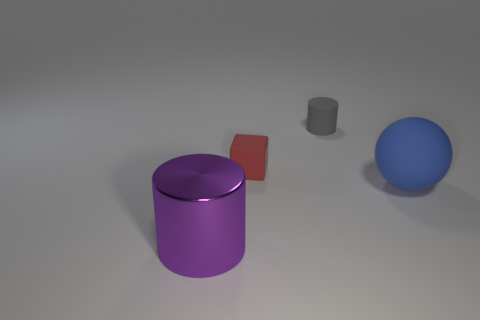Subtract all purple cylinders. How many cylinders are left? 1 Subtract 1 cylinders. How many cylinders are left? 1 Add 3 large blue rubber things. How many objects exist? 7 Subtract all blocks. How many objects are left? 3 Subtract all red spheres. How many blue cylinders are left? 0 Subtract 1 purple cylinders. How many objects are left? 3 Subtract all brown cylinders. Subtract all cyan balls. How many cylinders are left? 2 Subtract all big brown cylinders. Subtract all blocks. How many objects are left? 3 Add 4 balls. How many balls are left? 5 Add 2 tiny blocks. How many tiny blocks exist? 3 